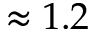<formula> <loc_0><loc_0><loc_500><loc_500>\approx 1 . 2</formula> 